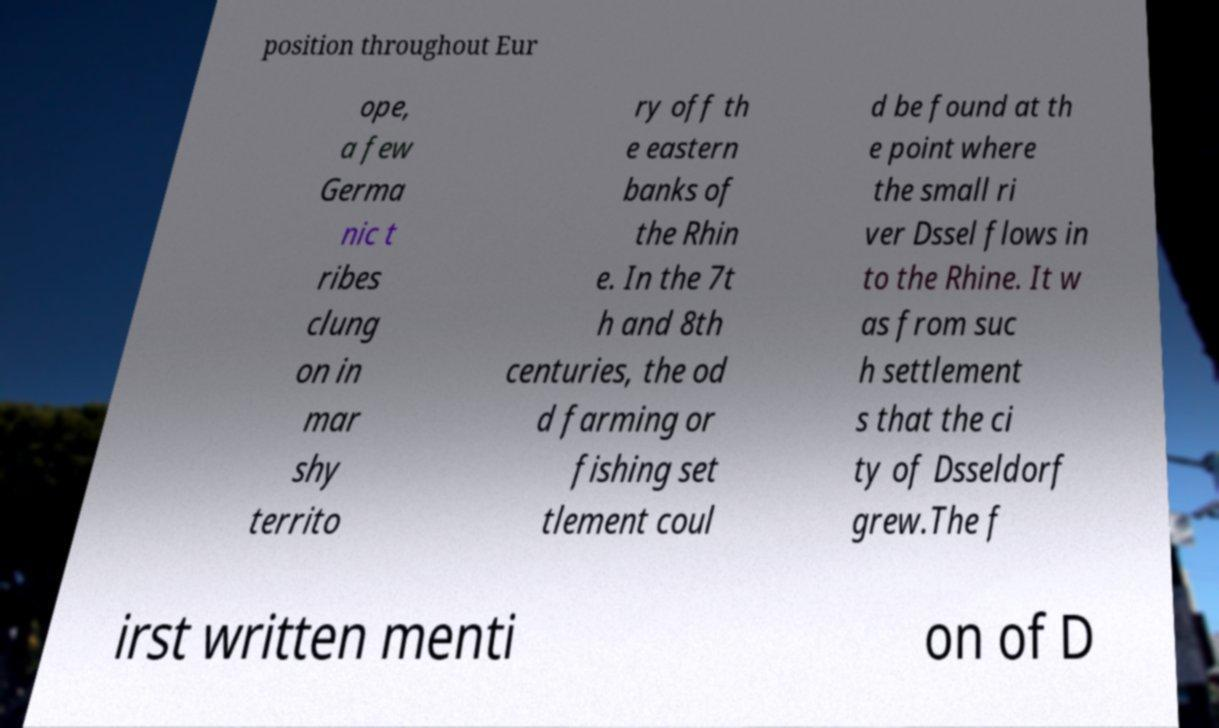There's text embedded in this image that I need extracted. Can you transcribe it verbatim? position throughout Eur ope, a few Germa nic t ribes clung on in mar shy territo ry off th e eastern banks of the Rhin e. In the 7t h and 8th centuries, the od d farming or fishing set tlement coul d be found at th e point where the small ri ver Dssel flows in to the Rhine. It w as from suc h settlement s that the ci ty of Dsseldorf grew.The f irst written menti on of D 